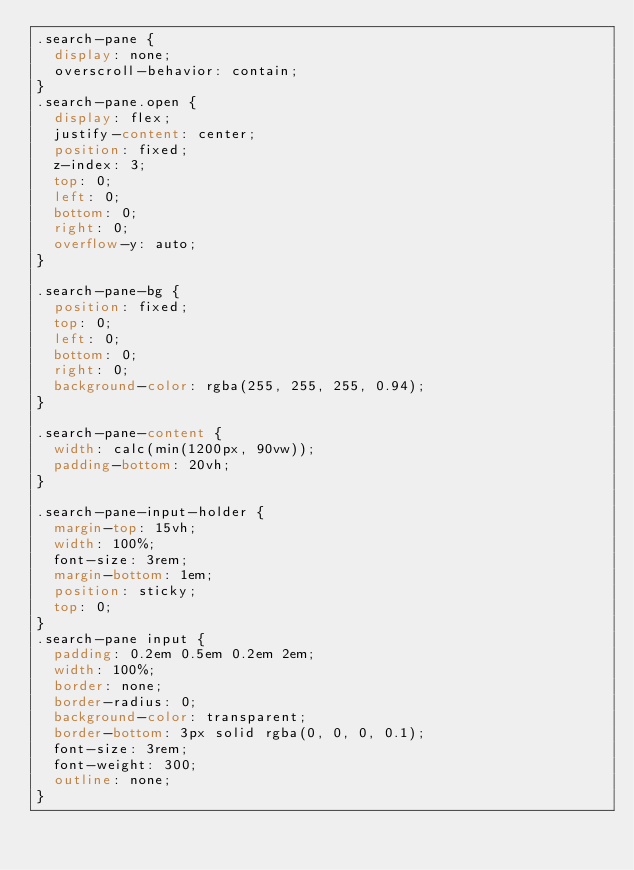<code> <loc_0><loc_0><loc_500><loc_500><_CSS_>.search-pane {
  display: none;
  overscroll-behavior: contain;
}
.search-pane.open {
  display: flex;
  justify-content: center;
  position: fixed;
  z-index: 3;
  top: 0;
  left: 0;
  bottom: 0;
  right: 0;
  overflow-y: auto;
}

.search-pane-bg {
  position: fixed;
  top: 0;
  left: 0;
  bottom: 0;
  right: 0;
  background-color: rgba(255, 255, 255, 0.94);
}

.search-pane-content {
  width: calc(min(1200px, 90vw));
  padding-bottom: 20vh;
}

.search-pane-input-holder {
  margin-top: 15vh;
  width: 100%;
  font-size: 3rem;
  margin-bottom: 1em;
  position: sticky;
  top: 0;
}
.search-pane input {
  padding: 0.2em 0.5em 0.2em 2em;
  width: 100%;
  border: none;
  border-radius: 0;
  background-color: transparent;
  border-bottom: 3px solid rgba(0, 0, 0, 0.1);
  font-size: 3rem;
  font-weight: 300;
  outline: none;
}
</code> 